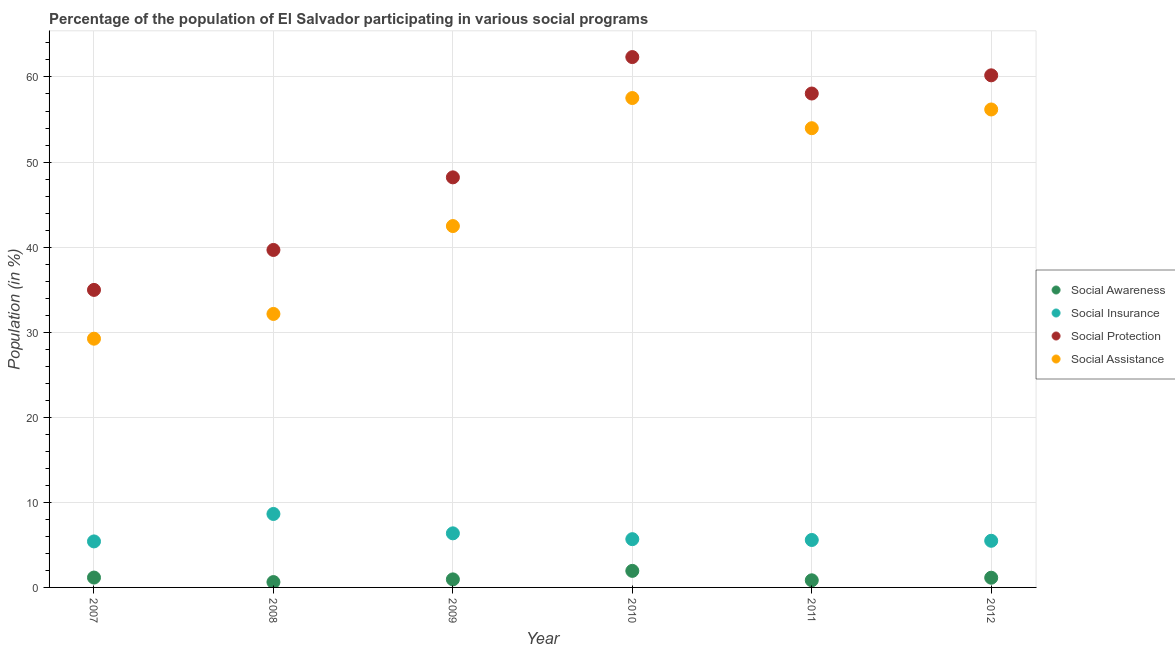Is the number of dotlines equal to the number of legend labels?
Keep it short and to the point. Yes. What is the participation of population in social insurance programs in 2007?
Your answer should be very brief. 5.41. Across all years, what is the maximum participation of population in social assistance programs?
Provide a short and direct response. 57.53. Across all years, what is the minimum participation of population in social assistance programs?
Your response must be concise. 29.24. What is the total participation of population in social assistance programs in the graph?
Provide a succinct answer. 271.55. What is the difference between the participation of population in social assistance programs in 2011 and that in 2012?
Provide a succinct answer. -2.2. What is the difference between the participation of population in social insurance programs in 2007 and the participation of population in social protection programs in 2010?
Provide a short and direct response. -56.93. What is the average participation of population in social awareness programs per year?
Offer a terse response. 1.11. In the year 2010, what is the difference between the participation of population in social awareness programs and participation of population in social assistance programs?
Offer a terse response. -55.58. What is the ratio of the participation of population in social assistance programs in 2008 to that in 2012?
Make the answer very short. 0.57. Is the participation of population in social insurance programs in 2007 less than that in 2010?
Offer a terse response. Yes. What is the difference between the highest and the second highest participation of population in social awareness programs?
Your answer should be very brief. 0.79. What is the difference between the highest and the lowest participation of population in social protection programs?
Provide a short and direct response. 27.37. In how many years, is the participation of population in social awareness programs greater than the average participation of population in social awareness programs taken over all years?
Your answer should be compact. 3. Is it the case that in every year, the sum of the participation of population in social assistance programs and participation of population in social protection programs is greater than the sum of participation of population in social insurance programs and participation of population in social awareness programs?
Provide a short and direct response. Yes. Is the participation of population in social protection programs strictly greater than the participation of population in social awareness programs over the years?
Your response must be concise. Yes. How many years are there in the graph?
Make the answer very short. 6. Are the values on the major ticks of Y-axis written in scientific E-notation?
Your answer should be compact. No. How many legend labels are there?
Give a very brief answer. 4. How are the legend labels stacked?
Your answer should be very brief. Vertical. What is the title of the graph?
Give a very brief answer. Percentage of the population of El Salvador participating in various social programs . What is the label or title of the X-axis?
Ensure brevity in your answer.  Year. What is the Population (in %) in Social Awareness in 2007?
Offer a terse response. 1.16. What is the Population (in %) of Social Insurance in 2007?
Your answer should be compact. 5.41. What is the Population (in %) in Social Protection in 2007?
Make the answer very short. 34.97. What is the Population (in %) in Social Assistance in 2007?
Keep it short and to the point. 29.24. What is the Population (in %) of Social Awareness in 2008?
Your response must be concise. 0.63. What is the Population (in %) in Social Insurance in 2008?
Give a very brief answer. 8.63. What is the Population (in %) of Social Protection in 2008?
Your answer should be compact. 39.67. What is the Population (in %) of Social Assistance in 2008?
Offer a very short reply. 32.15. What is the Population (in %) of Social Awareness in 2009?
Your response must be concise. 0.95. What is the Population (in %) in Social Insurance in 2009?
Ensure brevity in your answer.  6.36. What is the Population (in %) of Social Protection in 2009?
Your response must be concise. 48.2. What is the Population (in %) of Social Assistance in 2009?
Your response must be concise. 42.48. What is the Population (in %) of Social Awareness in 2010?
Your answer should be compact. 1.95. What is the Population (in %) of Social Insurance in 2010?
Your answer should be compact. 5.67. What is the Population (in %) in Social Protection in 2010?
Offer a terse response. 62.34. What is the Population (in %) in Social Assistance in 2010?
Your response must be concise. 57.53. What is the Population (in %) in Social Awareness in 2011?
Your response must be concise. 0.84. What is the Population (in %) in Social Insurance in 2011?
Make the answer very short. 5.58. What is the Population (in %) of Social Protection in 2011?
Your answer should be very brief. 58.06. What is the Population (in %) in Social Assistance in 2011?
Provide a short and direct response. 53.98. What is the Population (in %) of Social Awareness in 2012?
Give a very brief answer. 1.14. What is the Population (in %) of Social Insurance in 2012?
Your response must be concise. 5.48. What is the Population (in %) of Social Protection in 2012?
Your response must be concise. 60.19. What is the Population (in %) of Social Assistance in 2012?
Ensure brevity in your answer.  56.18. Across all years, what is the maximum Population (in %) in Social Awareness?
Make the answer very short. 1.95. Across all years, what is the maximum Population (in %) in Social Insurance?
Provide a succinct answer. 8.63. Across all years, what is the maximum Population (in %) of Social Protection?
Provide a succinct answer. 62.34. Across all years, what is the maximum Population (in %) of Social Assistance?
Give a very brief answer. 57.53. Across all years, what is the minimum Population (in %) of Social Awareness?
Give a very brief answer. 0.63. Across all years, what is the minimum Population (in %) in Social Insurance?
Offer a terse response. 5.41. Across all years, what is the minimum Population (in %) of Social Protection?
Provide a succinct answer. 34.97. Across all years, what is the minimum Population (in %) of Social Assistance?
Make the answer very short. 29.24. What is the total Population (in %) in Social Awareness in the graph?
Offer a terse response. 6.66. What is the total Population (in %) in Social Insurance in the graph?
Offer a terse response. 37.13. What is the total Population (in %) of Social Protection in the graph?
Your answer should be very brief. 303.43. What is the total Population (in %) of Social Assistance in the graph?
Your answer should be compact. 271.55. What is the difference between the Population (in %) in Social Awareness in 2007 and that in 2008?
Ensure brevity in your answer.  0.53. What is the difference between the Population (in %) in Social Insurance in 2007 and that in 2008?
Provide a short and direct response. -3.23. What is the difference between the Population (in %) of Social Protection in 2007 and that in 2008?
Your response must be concise. -4.7. What is the difference between the Population (in %) in Social Assistance in 2007 and that in 2008?
Your response must be concise. -2.91. What is the difference between the Population (in %) in Social Awareness in 2007 and that in 2009?
Your answer should be very brief. 0.21. What is the difference between the Population (in %) of Social Insurance in 2007 and that in 2009?
Your answer should be compact. -0.95. What is the difference between the Population (in %) in Social Protection in 2007 and that in 2009?
Keep it short and to the point. -13.23. What is the difference between the Population (in %) in Social Assistance in 2007 and that in 2009?
Give a very brief answer. -13.24. What is the difference between the Population (in %) of Social Awareness in 2007 and that in 2010?
Provide a succinct answer. -0.79. What is the difference between the Population (in %) of Social Insurance in 2007 and that in 2010?
Your answer should be very brief. -0.26. What is the difference between the Population (in %) in Social Protection in 2007 and that in 2010?
Offer a very short reply. -27.37. What is the difference between the Population (in %) of Social Assistance in 2007 and that in 2010?
Your answer should be very brief. -28.29. What is the difference between the Population (in %) in Social Awareness in 2007 and that in 2011?
Ensure brevity in your answer.  0.32. What is the difference between the Population (in %) in Social Insurance in 2007 and that in 2011?
Your answer should be compact. -0.17. What is the difference between the Population (in %) of Social Protection in 2007 and that in 2011?
Make the answer very short. -23.08. What is the difference between the Population (in %) of Social Assistance in 2007 and that in 2011?
Ensure brevity in your answer.  -24.74. What is the difference between the Population (in %) of Social Awareness in 2007 and that in 2012?
Make the answer very short. 0.02. What is the difference between the Population (in %) of Social Insurance in 2007 and that in 2012?
Your answer should be very brief. -0.07. What is the difference between the Population (in %) of Social Protection in 2007 and that in 2012?
Provide a succinct answer. -25.22. What is the difference between the Population (in %) in Social Assistance in 2007 and that in 2012?
Provide a succinct answer. -26.94. What is the difference between the Population (in %) of Social Awareness in 2008 and that in 2009?
Offer a terse response. -0.32. What is the difference between the Population (in %) of Social Insurance in 2008 and that in 2009?
Ensure brevity in your answer.  2.28. What is the difference between the Population (in %) of Social Protection in 2008 and that in 2009?
Keep it short and to the point. -8.53. What is the difference between the Population (in %) of Social Assistance in 2008 and that in 2009?
Make the answer very short. -10.33. What is the difference between the Population (in %) in Social Awareness in 2008 and that in 2010?
Provide a succinct answer. -1.32. What is the difference between the Population (in %) in Social Insurance in 2008 and that in 2010?
Your answer should be very brief. 2.96. What is the difference between the Population (in %) in Social Protection in 2008 and that in 2010?
Provide a short and direct response. -22.67. What is the difference between the Population (in %) in Social Assistance in 2008 and that in 2010?
Give a very brief answer. -25.38. What is the difference between the Population (in %) in Social Awareness in 2008 and that in 2011?
Offer a very short reply. -0.21. What is the difference between the Population (in %) in Social Insurance in 2008 and that in 2011?
Give a very brief answer. 3.06. What is the difference between the Population (in %) in Social Protection in 2008 and that in 2011?
Your answer should be compact. -18.39. What is the difference between the Population (in %) in Social Assistance in 2008 and that in 2011?
Ensure brevity in your answer.  -21.83. What is the difference between the Population (in %) of Social Awareness in 2008 and that in 2012?
Provide a short and direct response. -0.51. What is the difference between the Population (in %) of Social Insurance in 2008 and that in 2012?
Offer a very short reply. 3.15. What is the difference between the Population (in %) of Social Protection in 2008 and that in 2012?
Offer a terse response. -20.53. What is the difference between the Population (in %) in Social Assistance in 2008 and that in 2012?
Your response must be concise. -24.03. What is the difference between the Population (in %) of Social Awareness in 2009 and that in 2010?
Keep it short and to the point. -1. What is the difference between the Population (in %) of Social Insurance in 2009 and that in 2010?
Your answer should be compact. 0.68. What is the difference between the Population (in %) in Social Protection in 2009 and that in 2010?
Ensure brevity in your answer.  -14.14. What is the difference between the Population (in %) in Social Assistance in 2009 and that in 2010?
Your answer should be compact. -15.05. What is the difference between the Population (in %) of Social Awareness in 2009 and that in 2011?
Your answer should be very brief. 0.11. What is the difference between the Population (in %) in Social Insurance in 2009 and that in 2011?
Keep it short and to the point. 0.78. What is the difference between the Population (in %) of Social Protection in 2009 and that in 2011?
Give a very brief answer. -9.86. What is the difference between the Population (in %) in Social Assistance in 2009 and that in 2011?
Keep it short and to the point. -11.5. What is the difference between the Population (in %) in Social Awareness in 2009 and that in 2012?
Offer a terse response. -0.2. What is the difference between the Population (in %) of Social Insurance in 2009 and that in 2012?
Your answer should be compact. 0.88. What is the difference between the Population (in %) of Social Protection in 2009 and that in 2012?
Give a very brief answer. -11.99. What is the difference between the Population (in %) in Social Assistance in 2009 and that in 2012?
Ensure brevity in your answer.  -13.7. What is the difference between the Population (in %) in Social Awareness in 2010 and that in 2011?
Provide a succinct answer. 1.11. What is the difference between the Population (in %) in Social Insurance in 2010 and that in 2011?
Your answer should be compact. 0.1. What is the difference between the Population (in %) in Social Protection in 2010 and that in 2011?
Provide a succinct answer. 4.28. What is the difference between the Population (in %) of Social Assistance in 2010 and that in 2011?
Offer a very short reply. 3.55. What is the difference between the Population (in %) of Social Awareness in 2010 and that in 2012?
Your answer should be compact. 0.8. What is the difference between the Population (in %) in Social Insurance in 2010 and that in 2012?
Ensure brevity in your answer.  0.19. What is the difference between the Population (in %) of Social Protection in 2010 and that in 2012?
Your answer should be compact. 2.15. What is the difference between the Population (in %) of Social Assistance in 2010 and that in 2012?
Make the answer very short. 1.34. What is the difference between the Population (in %) of Social Awareness in 2011 and that in 2012?
Provide a succinct answer. -0.3. What is the difference between the Population (in %) of Social Insurance in 2011 and that in 2012?
Provide a short and direct response. 0.09. What is the difference between the Population (in %) of Social Protection in 2011 and that in 2012?
Make the answer very short. -2.14. What is the difference between the Population (in %) of Social Assistance in 2011 and that in 2012?
Your answer should be very brief. -2.2. What is the difference between the Population (in %) in Social Awareness in 2007 and the Population (in %) in Social Insurance in 2008?
Keep it short and to the point. -7.48. What is the difference between the Population (in %) in Social Awareness in 2007 and the Population (in %) in Social Protection in 2008?
Make the answer very short. -38.51. What is the difference between the Population (in %) in Social Awareness in 2007 and the Population (in %) in Social Assistance in 2008?
Make the answer very short. -30.99. What is the difference between the Population (in %) of Social Insurance in 2007 and the Population (in %) of Social Protection in 2008?
Provide a succinct answer. -34.26. What is the difference between the Population (in %) in Social Insurance in 2007 and the Population (in %) in Social Assistance in 2008?
Offer a terse response. -26.74. What is the difference between the Population (in %) in Social Protection in 2007 and the Population (in %) in Social Assistance in 2008?
Give a very brief answer. 2.83. What is the difference between the Population (in %) in Social Awareness in 2007 and the Population (in %) in Social Insurance in 2009?
Offer a very short reply. -5.2. What is the difference between the Population (in %) in Social Awareness in 2007 and the Population (in %) in Social Protection in 2009?
Ensure brevity in your answer.  -47.04. What is the difference between the Population (in %) of Social Awareness in 2007 and the Population (in %) of Social Assistance in 2009?
Offer a terse response. -41.32. What is the difference between the Population (in %) in Social Insurance in 2007 and the Population (in %) in Social Protection in 2009?
Ensure brevity in your answer.  -42.79. What is the difference between the Population (in %) in Social Insurance in 2007 and the Population (in %) in Social Assistance in 2009?
Your answer should be compact. -37.07. What is the difference between the Population (in %) of Social Protection in 2007 and the Population (in %) of Social Assistance in 2009?
Keep it short and to the point. -7.5. What is the difference between the Population (in %) in Social Awareness in 2007 and the Population (in %) in Social Insurance in 2010?
Your answer should be very brief. -4.51. What is the difference between the Population (in %) in Social Awareness in 2007 and the Population (in %) in Social Protection in 2010?
Make the answer very short. -61.18. What is the difference between the Population (in %) of Social Awareness in 2007 and the Population (in %) of Social Assistance in 2010?
Your answer should be very brief. -56.37. What is the difference between the Population (in %) of Social Insurance in 2007 and the Population (in %) of Social Protection in 2010?
Make the answer very short. -56.93. What is the difference between the Population (in %) in Social Insurance in 2007 and the Population (in %) in Social Assistance in 2010?
Your answer should be compact. -52.12. What is the difference between the Population (in %) of Social Protection in 2007 and the Population (in %) of Social Assistance in 2010?
Your answer should be compact. -22.55. What is the difference between the Population (in %) of Social Awareness in 2007 and the Population (in %) of Social Insurance in 2011?
Make the answer very short. -4.42. What is the difference between the Population (in %) of Social Awareness in 2007 and the Population (in %) of Social Protection in 2011?
Provide a succinct answer. -56.9. What is the difference between the Population (in %) in Social Awareness in 2007 and the Population (in %) in Social Assistance in 2011?
Offer a very short reply. -52.82. What is the difference between the Population (in %) of Social Insurance in 2007 and the Population (in %) of Social Protection in 2011?
Make the answer very short. -52.65. What is the difference between the Population (in %) in Social Insurance in 2007 and the Population (in %) in Social Assistance in 2011?
Keep it short and to the point. -48.57. What is the difference between the Population (in %) of Social Protection in 2007 and the Population (in %) of Social Assistance in 2011?
Your response must be concise. -19.01. What is the difference between the Population (in %) in Social Awareness in 2007 and the Population (in %) in Social Insurance in 2012?
Provide a short and direct response. -4.32. What is the difference between the Population (in %) in Social Awareness in 2007 and the Population (in %) in Social Protection in 2012?
Make the answer very short. -59.03. What is the difference between the Population (in %) of Social Awareness in 2007 and the Population (in %) of Social Assistance in 2012?
Provide a succinct answer. -55.02. What is the difference between the Population (in %) in Social Insurance in 2007 and the Population (in %) in Social Protection in 2012?
Provide a succinct answer. -54.79. What is the difference between the Population (in %) in Social Insurance in 2007 and the Population (in %) in Social Assistance in 2012?
Your response must be concise. -50.77. What is the difference between the Population (in %) in Social Protection in 2007 and the Population (in %) in Social Assistance in 2012?
Your answer should be compact. -21.21. What is the difference between the Population (in %) of Social Awareness in 2008 and the Population (in %) of Social Insurance in 2009?
Offer a terse response. -5.73. What is the difference between the Population (in %) of Social Awareness in 2008 and the Population (in %) of Social Protection in 2009?
Make the answer very short. -47.57. What is the difference between the Population (in %) of Social Awareness in 2008 and the Population (in %) of Social Assistance in 2009?
Make the answer very short. -41.85. What is the difference between the Population (in %) of Social Insurance in 2008 and the Population (in %) of Social Protection in 2009?
Give a very brief answer. -39.57. What is the difference between the Population (in %) in Social Insurance in 2008 and the Population (in %) in Social Assistance in 2009?
Offer a very short reply. -33.84. What is the difference between the Population (in %) of Social Protection in 2008 and the Population (in %) of Social Assistance in 2009?
Keep it short and to the point. -2.81. What is the difference between the Population (in %) in Social Awareness in 2008 and the Population (in %) in Social Insurance in 2010?
Your answer should be very brief. -5.04. What is the difference between the Population (in %) in Social Awareness in 2008 and the Population (in %) in Social Protection in 2010?
Your answer should be compact. -61.71. What is the difference between the Population (in %) of Social Awareness in 2008 and the Population (in %) of Social Assistance in 2010?
Provide a succinct answer. -56.9. What is the difference between the Population (in %) of Social Insurance in 2008 and the Population (in %) of Social Protection in 2010?
Your response must be concise. -53.71. What is the difference between the Population (in %) in Social Insurance in 2008 and the Population (in %) in Social Assistance in 2010?
Provide a short and direct response. -48.89. What is the difference between the Population (in %) in Social Protection in 2008 and the Population (in %) in Social Assistance in 2010?
Make the answer very short. -17.86. What is the difference between the Population (in %) of Social Awareness in 2008 and the Population (in %) of Social Insurance in 2011?
Your answer should be compact. -4.95. What is the difference between the Population (in %) of Social Awareness in 2008 and the Population (in %) of Social Protection in 2011?
Your response must be concise. -57.43. What is the difference between the Population (in %) of Social Awareness in 2008 and the Population (in %) of Social Assistance in 2011?
Keep it short and to the point. -53.35. What is the difference between the Population (in %) of Social Insurance in 2008 and the Population (in %) of Social Protection in 2011?
Offer a terse response. -49.42. What is the difference between the Population (in %) of Social Insurance in 2008 and the Population (in %) of Social Assistance in 2011?
Offer a terse response. -45.34. What is the difference between the Population (in %) of Social Protection in 2008 and the Population (in %) of Social Assistance in 2011?
Provide a short and direct response. -14.31. What is the difference between the Population (in %) of Social Awareness in 2008 and the Population (in %) of Social Insurance in 2012?
Give a very brief answer. -4.85. What is the difference between the Population (in %) in Social Awareness in 2008 and the Population (in %) in Social Protection in 2012?
Keep it short and to the point. -59.57. What is the difference between the Population (in %) of Social Awareness in 2008 and the Population (in %) of Social Assistance in 2012?
Give a very brief answer. -55.55. What is the difference between the Population (in %) in Social Insurance in 2008 and the Population (in %) in Social Protection in 2012?
Give a very brief answer. -51.56. What is the difference between the Population (in %) of Social Insurance in 2008 and the Population (in %) of Social Assistance in 2012?
Provide a short and direct response. -47.55. What is the difference between the Population (in %) of Social Protection in 2008 and the Population (in %) of Social Assistance in 2012?
Ensure brevity in your answer.  -16.51. What is the difference between the Population (in %) in Social Awareness in 2009 and the Population (in %) in Social Insurance in 2010?
Your answer should be compact. -4.73. What is the difference between the Population (in %) in Social Awareness in 2009 and the Population (in %) in Social Protection in 2010?
Offer a terse response. -61.4. What is the difference between the Population (in %) of Social Awareness in 2009 and the Population (in %) of Social Assistance in 2010?
Offer a terse response. -56.58. What is the difference between the Population (in %) of Social Insurance in 2009 and the Population (in %) of Social Protection in 2010?
Offer a terse response. -55.98. What is the difference between the Population (in %) in Social Insurance in 2009 and the Population (in %) in Social Assistance in 2010?
Your response must be concise. -51.17. What is the difference between the Population (in %) of Social Protection in 2009 and the Population (in %) of Social Assistance in 2010?
Keep it short and to the point. -9.32. What is the difference between the Population (in %) in Social Awareness in 2009 and the Population (in %) in Social Insurance in 2011?
Give a very brief answer. -4.63. What is the difference between the Population (in %) of Social Awareness in 2009 and the Population (in %) of Social Protection in 2011?
Your answer should be compact. -57.11. What is the difference between the Population (in %) of Social Awareness in 2009 and the Population (in %) of Social Assistance in 2011?
Your answer should be very brief. -53.03. What is the difference between the Population (in %) in Social Insurance in 2009 and the Population (in %) in Social Protection in 2011?
Give a very brief answer. -51.7. What is the difference between the Population (in %) in Social Insurance in 2009 and the Population (in %) in Social Assistance in 2011?
Offer a terse response. -47.62. What is the difference between the Population (in %) in Social Protection in 2009 and the Population (in %) in Social Assistance in 2011?
Ensure brevity in your answer.  -5.78. What is the difference between the Population (in %) in Social Awareness in 2009 and the Population (in %) in Social Insurance in 2012?
Your answer should be compact. -4.54. What is the difference between the Population (in %) of Social Awareness in 2009 and the Population (in %) of Social Protection in 2012?
Offer a very short reply. -59.25. What is the difference between the Population (in %) in Social Awareness in 2009 and the Population (in %) in Social Assistance in 2012?
Provide a short and direct response. -55.24. What is the difference between the Population (in %) of Social Insurance in 2009 and the Population (in %) of Social Protection in 2012?
Your response must be concise. -53.84. What is the difference between the Population (in %) in Social Insurance in 2009 and the Population (in %) in Social Assistance in 2012?
Your answer should be very brief. -49.82. What is the difference between the Population (in %) in Social Protection in 2009 and the Population (in %) in Social Assistance in 2012?
Keep it short and to the point. -7.98. What is the difference between the Population (in %) of Social Awareness in 2010 and the Population (in %) of Social Insurance in 2011?
Offer a terse response. -3.63. What is the difference between the Population (in %) in Social Awareness in 2010 and the Population (in %) in Social Protection in 2011?
Make the answer very short. -56.11. What is the difference between the Population (in %) in Social Awareness in 2010 and the Population (in %) in Social Assistance in 2011?
Provide a succinct answer. -52.03. What is the difference between the Population (in %) of Social Insurance in 2010 and the Population (in %) of Social Protection in 2011?
Make the answer very short. -52.38. What is the difference between the Population (in %) of Social Insurance in 2010 and the Population (in %) of Social Assistance in 2011?
Offer a very short reply. -48.31. What is the difference between the Population (in %) in Social Protection in 2010 and the Population (in %) in Social Assistance in 2011?
Offer a very short reply. 8.36. What is the difference between the Population (in %) in Social Awareness in 2010 and the Population (in %) in Social Insurance in 2012?
Provide a short and direct response. -3.54. What is the difference between the Population (in %) of Social Awareness in 2010 and the Population (in %) of Social Protection in 2012?
Offer a very short reply. -58.25. What is the difference between the Population (in %) of Social Awareness in 2010 and the Population (in %) of Social Assistance in 2012?
Provide a short and direct response. -54.24. What is the difference between the Population (in %) of Social Insurance in 2010 and the Population (in %) of Social Protection in 2012?
Your answer should be very brief. -54.52. What is the difference between the Population (in %) in Social Insurance in 2010 and the Population (in %) in Social Assistance in 2012?
Your response must be concise. -50.51. What is the difference between the Population (in %) in Social Protection in 2010 and the Population (in %) in Social Assistance in 2012?
Your answer should be compact. 6.16. What is the difference between the Population (in %) in Social Awareness in 2011 and the Population (in %) in Social Insurance in 2012?
Keep it short and to the point. -4.65. What is the difference between the Population (in %) of Social Awareness in 2011 and the Population (in %) of Social Protection in 2012?
Give a very brief answer. -59.36. What is the difference between the Population (in %) of Social Awareness in 2011 and the Population (in %) of Social Assistance in 2012?
Your answer should be very brief. -55.34. What is the difference between the Population (in %) in Social Insurance in 2011 and the Population (in %) in Social Protection in 2012?
Offer a terse response. -54.62. What is the difference between the Population (in %) of Social Insurance in 2011 and the Population (in %) of Social Assistance in 2012?
Keep it short and to the point. -50.6. What is the difference between the Population (in %) in Social Protection in 2011 and the Population (in %) in Social Assistance in 2012?
Provide a succinct answer. 1.88. What is the average Population (in %) in Social Awareness per year?
Give a very brief answer. 1.11. What is the average Population (in %) in Social Insurance per year?
Offer a very short reply. 6.19. What is the average Population (in %) of Social Protection per year?
Make the answer very short. 50.57. What is the average Population (in %) in Social Assistance per year?
Provide a short and direct response. 45.26. In the year 2007, what is the difference between the Population (in %) in Social Awareness and Population (in %) in Social Insurance?
Offer a terse response. -4.25. In the year 2007, what is the difference between the Population (in %) in Social Awareness and Population (in %) in Social Protection?
Offer a very short reply. -33.81. In the year 2007, what is the difference between the Population (in %) in Social Awareness and Population (in %) in Social Assistance?
Offer a terse response. -28.08. In the year 2007, what is the difference between the Population (in %) of Social Insurance and Population (in %) of Social Protection?
Give a very brief answer. -29.56. In the year 2007, what is the difference between the Population (in %) of Social Insurance and Population (in %) of Social Assistance?
Ensure brevity in your answer.  -23.83. In the year 2007, what is the difference between the Population (in %) in Social Protection and Population (in %) in Social Assistance?
Give a very brief answer. 5.74. In the year 2008, what is the difference between the Population (in %) of Social Awareness and Population (in %) of Social Insurance?
Provide a succinct answer. -8.01. In the year 2008, what is the difference between the Population (in %) in Social Awareness and Population (in %) in Social Protection?
Give a very brief answer. -39.04. In the year 2008, what is the difference between the Population (in %) in Social Awareness and Population (in %) in Social Assistance?
Offer a terse response. -31.52. In the year 2008, what is the difference between the Population (in %) of Social Insurance and Population (in %) of Social Protection?
Provide a short and direct response. -31.03. In the year 2008, what is the difference between the Population (in %) in Social Insurance and Population (in %) in Social Assistance?
Your answer should be very brief. -23.51. In the year 2008, what is the difference between the Population (in %) of Social Protection and Population (in %) of Social Assistance?
Offer a terse response. 7.52. In the year 2009, what is the difference between the Population (in %) of Social Awareness and Population (in %) of Social Insurance?
Your answer should be very brief. -5.41. In the year 2009, what is the difference between the Population (in %) in Social Awareness and Population (in %) in Social Protection?
Make the answer very short. -47.26. In the year 2009, what is the difference between the Population (in %) of Social Awareness and Population (in %) of Social Assistance?
Offer a terse response. -41.53. In the year 2009, what is the difference between the Population (in %) of Social Insurance and Population (in %) of Social Protection?
Make the answer very short. -41.84. In the year 2009, what is the difference between the Population (in %) in Social Insurance and Population (in %) in Social Assistance?
Give a very brief answer. -36.12. In the year 2009, what is the difference between the Population (in %) in Social Protection and Population (in %) in Social Assistance?
Offer a terse response. 5.72. In the year 2010, what is the difference between the Population (in %) of Social Awareness and Population (in %) of Social Insurance?
Provide a succinct answer. -3.73. In the year 2010, what is the difference between the Population (in %) of Social Awareness and Population (in %) of Social Protection?
Your answer should be very brief. -60.39. In the year 2010, what is the difference between the Population (in %) of Social Awareness and Population (in %) of Social Assistance?
Provide a short and direct response. -55.58. In the year 2010, what is the difference between the Population (in %) in Social Insurance and Population (in %) in Social Protection?
Ensure brevity in your answer.  -56.67. In the year 2010, what is the difference between the Population (in %) in Social Insurance and Population (in %) in Social Assistance?
Your response must be concise. -51.85. In the year 2010, what is the difference between the Population (in %) of Social Protection and Population (in %) of Social Assistance?
Your response must be concise. 4.82. In the year 2011, what is the difference between the Population (in %) of Social Awareness and Population (in %) of Social Insurance?
Your answer should be very brief. -4.74. In the year 2011, what is the difference between the Population (in %) of Social Awareness and Population (in %) of Social Protection?
Offer a terse response. -57.22. In the year 2011, what is the difference between the Population (in %) of Social Awareness and Population (in %) of Social Assistance?
Provide a succinct answer. -53.14. In the year 2011, what is the difference between the Population (in %) in Social Insurance and Population (in %) in Social Protection?
Give a very brief answer. -52.48. In the year 2011, what is the difference between the Population (in %) of Social Insurance and Population (in %) of Social Assistance?
Provide a succinct answer. -48.4. In the year 2011, what is the difference between the Population (in %) in Social Protection and Population (in %) in Social Assistance?
Offer a terse response. 4.08. In the year 2012, what is the difference between the Population (in %) in Social Awareness and Population (in %) in Social Insurance?
Make the answer very short. -4.34. In the year 2012, what is the difference between the Population (in %) in Social Awareness and Population (in %) in Social Protection?
Your answer should be very brief. -59.05. In the year 2012, what is the difference between the Population (in %) in Social Awareness and Population (in %) in Social Assistance?
Offer a terse response. -55.04. In the year 2012, what is the difference between the Population (in %) of Social Insurance and Population (in %) of Social Protection?
Your response must be concise. -54.71. In the year 2012, what is the difference between the Population (in %) in Social Insurance and Population (in %) in Social Assistance?
Ensure brevity in your answer.  -50.7. In the year 2012, what is the difference between the Population (in %) in Social Protection and Population (in %) in Social Assistance?
Your answer should be very brief. 4.01. What is the ratio of the Population (in %) in Social Awareness in 2007 to that in 2008?
Your answer should be compact. 1.84. What is the ratio of the Population (in %) in Social Insurance in 2007 to that in 2008?
Provide a succinct answer. 0.63. What is the ratio of the Population (in %) in Social Protection in 2007 to that in 2008?
Give a very brief answer. 0.88. What is the ratio of the Population (in %) of Social Assistance in 2007 to that in 2008?
Offer a very short reply. 0.91. What is the ratio of the Population (in %) of Social Awareness in 2007 to that in 2009?
Offer a very short reply. 1.23. What is the ratio of the Population (in %) in Social Insurance in 2007 to that in 2009?
Keep it short and to the point. 0.85. What is the ratio of the Population (in %) of Social Protection in 2007 to that in 2009?
Give a very brief answer. 0.73. What is the ratio of the Population (in %) in Social Assistance in 2007 to that in 2009?
Offer a very short reply. 0.69. What is the ratio of the Population (in %) of Social Awareness in 2007 to that in 2010?
Make the answer very short. 0.6. What is the ratio of the Population (in %) of Social Insurance in 2007 to that in 2010?
Make the answer very short. 0.95. What is the ratio of the Population (in %) in Social Protection in 2007 to that in 2010?
Make the answer very short. 0.56. What is the ratio of the Population (in %) in Social Assistance in 2007 to that in 2010?
Your answer should be compact. 0.51. What is the ratio of the Population (in %) in Social Awareness in 2007 to that in 2011?
Give a very brief answer. 1.38. What is the ratio of the Population (in %) in Social Insurance in 2007 to that in 2011?
Keep it short and to the point. 0.97. What is the ratio of the Population (in %) of Social Protection in 2007 to that in 2011?
Your response must be concise. 0.6. What is the ratio of the Population (in %) in Social Assistance in 2007 to that in 2011?
Make the answer very short. 0.54. What is the ratio of the Population (in %) in Social Awareness in 2007 to that in 2012?
Provide a short and direct response. 1.02. What is the ratio of the Population (in %) in Social Insurance in 2007 to that in 2012?
Your response must be concise. 0.99. What is the ratio of the Population (in %) in Social Protection in 2007 to that in 2012?
Your answer should be very brief. 0.58. What is the ratio of the Population (in %) in Social Assistance in 2007 to that in 2012?
Your response must be concise. 0.52. What is the ratio of the Population (in %) in Social Awareness in 2008 to that in 2009?
Ensure brevity in your answer.  0.67. What is the ratio of the Population (in %) of Social Insurance in 2008 to that in 2009?
Provide a short and direct response. 1.36. What is the ratio of the Population (in %) in Social Protection in 2008 to that in 2009?
Offer a terse response. 0.82. What is the ratio of the Population (in %) of Social Assistance in 2008 to that in 2009?
Offer a very short reply. 0.76. What is the ratio of the Population (in %) in Social Awareness in 2008 to that in 2010?
Offer a very short reply. 0.32. What is the ratio of the Population (in %) in Social Insurance in 2008 to that in 2010?
Your response must be concise. 1.52. What is the ratio of the Population (in %) of Social Protection in 2008 to that in 2010?
Keep it short and to the point. 0.64. What is the ratio of the Population (in %) in Social Assistance in 2008 to that in 2010?
Make the answer very short. 0.56. What is the ratio of the Population (in %) of Social Awareness in 2008 to that in 2011?
Keep it short and to the point. 0.75. What is the ratio of the Population (in %) in Social Insurance in 2008 to that in 2011?
Your answer should be compact. 1.55. What is the ratio of the Population (in %) of Social Protection in 2008 to that in 2011?
Your response must be concise. 0.68. What is the ratio of the Population (in %) in Social Assistance in 2008 to that in 2011?
Provide a succinct answer. 0.6. What is the ratio of the Population (in %) in Social Awareness in 2008 to that in 2012?
Your answer should be compact. 0.55. What is the ratio of the Population (in %) of Social Insurance in 2008 to that in 2012?
Provide a succinct answer. 1.57. What is the ratio of the Population (in %) of Social Protection in 2008 to that in 2012?
Keep it short and to the point. 0.66. What is the ratio of the Population (in %) of Social Assistance in 2008 to that in 2012?
Offer a very short reply. 0.57. What is the ratio of the Population (in %) of Social Awareness in 2009 to that in 2010?
Make the answer very short. 0.49. What is the ratio of the Population (in %) of Social Insurance in 2009 to that in 2010?
Provide a succinct answer. 1.12. What is the ratio of the Population (in %) in Social Protection in 2009 to that in 2010?
Offer a very short reply. 0.77. What is the ratio of the Population (in %) of Social Assistance in 2009 to that in 2010?
Make the answer very short. 0.74. What is the ratio of the Population (in %) of Social Awareness in 2009 to that in 2011?
Your response must be concise. 1.13. What is the ratio of the Population (in %) in Social Insurance in 2009 to that in 2011?
Provide a short and direct response. 1.14. What is the ratio of the Population (in %) in Social Protection in 2009 to that in 2011?
Give a very brief answer. 0.83. What is the ratio of the Population (in %) of Social Assistance in 2009 to that in 2011?
Make the answer very short. 0.79. What is the ratio of the Population (in %) in Social Awareness in 2009 to that in 2012?
Your answer should be compact. 0.83. What is the ratio of the Population (in %) in Social Insurance in 2009 to that in 2012?
Ensure brevity in your answer.  1.16. What is the ratio of the Population (in %) in Social Protection in 2009 to that in 2012?
Your response must be concise. 0.8. What is the ratio of the Population (in %) in Social Assistance in 2009 to that in 2012?
Your answer should be compact. 0.76. What is the ratio of the Population (in %) of Social Awareness in 2010 to that in 2011?
Keep it short and to the point. 2.32. What is the ratio of the Population (in %) of Social Insurance in 2010 to that in 2011?
Ensure brevity in your answer.  1.02. What is the ratio of the Population (in %) of Social Protection in 2010 to that in 2011?
Provide a succinct answer. 1.07. What is the ratio of the Population (in %) of Social Assistance in 2010 to that in 2011?
Offer a very short reply. 1.07. What is the ratio of the Population (in %) of Social Awareness in 2010 to that in 2012?
Provide a succinct answer. 1.71. What is the ratio of the Population (in %) of Social Insurance in 2010 to that in 2012?
Keep it short and to the point. 1.03. What is the ratio of the Population (in %) of Social Protection in 2010 to that in 2012?
Provide a short and direct response. 1.04. What is the ratio of the Population (in %) of Social Assistance in 2010 to that in 2012?
Offer a very short reply. 1.02. What is the ratio of the Population (in %) in Social Awareness in 2011 to that in 2012?
Make the answer very short. 0.73. What is the ratio of the Population (in %) in Social Insurance in 2011 to that in 2012?
Your answer should be compact. 1.02. What is the ratio of the Population (in %) of Social Protection in 2011 to that in 2012?
Make the answer very short. 0.96. What is the ratio of the Population (in %) of Social Assistance in 2011 to that in 2012?
Your response must be concise. 0.96. What is the difference between the highest and the second highest Population (in %) in Social Awareness?
Keep it short and to the point. 0.79. What is the difference between the highest and the second highest Population (in %) of Social Insurance?
Ensure brevity in your answer.  2.28. What is the difference between the highest and the second highest Population (in %) of Social Protection?
Provide a short and direct response. 2.15. What is the difference between the highest and the second highest Population (in %) of Social Assistance?
Your response must be concise. 1.34. What is the difference between the highest and the lowest Population (in %) of Social Awareness?
Offer a terse response. 1.32. What is the difference between the highest and the lowest Population (in %) in Social Insurance?
Your answer should be compact. 3.23. What is the difference between the highest and the lowest Population (in %) in Social Protection?
Provide a succinct answer. 27.37. What is the difference between the highest and the lowest Population (in %) of Social Assistance?
Make the answer very short. 28.29. 